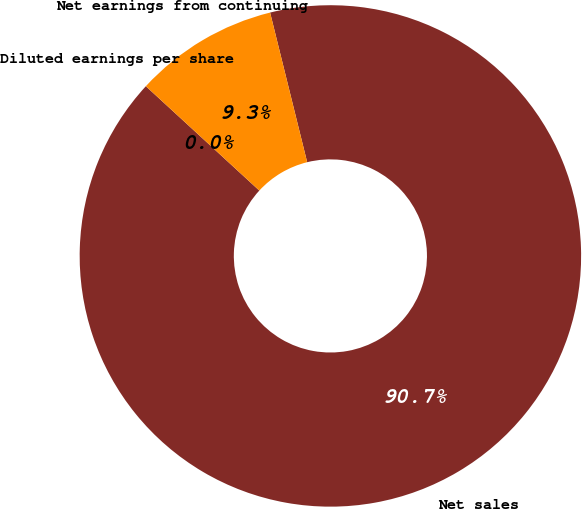<chart> <loc_0><loc_0><loc_500><loc_500><pie_chart><fcel>Net sales<fcel>Net earnings from continuing<fcel>Diluted earnings per share<nl><fcel>90.7%<fcel>9.3%<fcel>0.0%<nl></chart> 